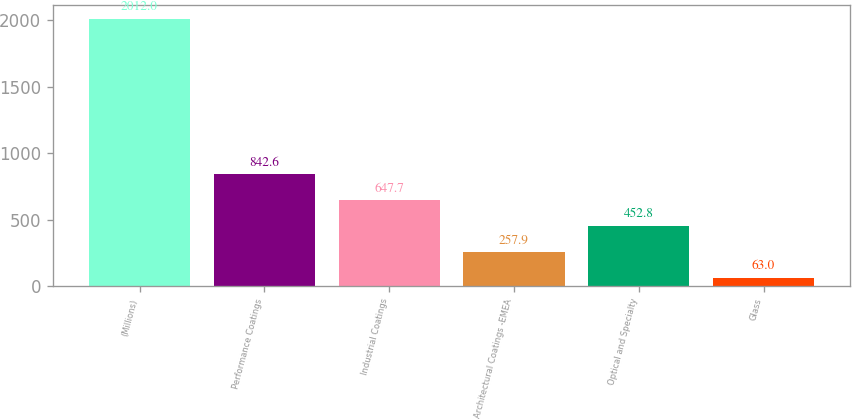Convert chart to OTSL. <chart><loc_0><loc_0><loc_500><loc_500><bar_chart><fcel>(Millions)<fcel>Performance Coatings<fcel>Industrial Coatings<fcel>Architectural Coatings -EMEA<fcel>Optical and Specialty<fcel>Glass<nl><fcel>2012<fcel>842.6<fcel>647.7<fcel>257.9<fcel>452.8<fcel>63<nl></chart> 